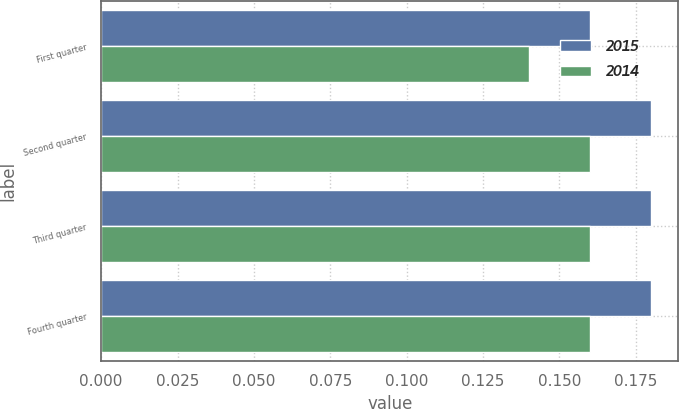Convert chart. <chart><loc_0><loc_0><loc_500><loc_500><stacked_bar_chart><ecel><fcel>First quarter<fcel>Second quarter<fcel>Third quarter<fcel>Fourth quarter<nl><fcel>2015<fcel>0.16<fcel>0.18<fcel>0.18<fcel>0.18<nl><fcel>2014<fcel>0.14<fcel>0.16<fcel>0.16<fcel>0.16<nl></chart> 